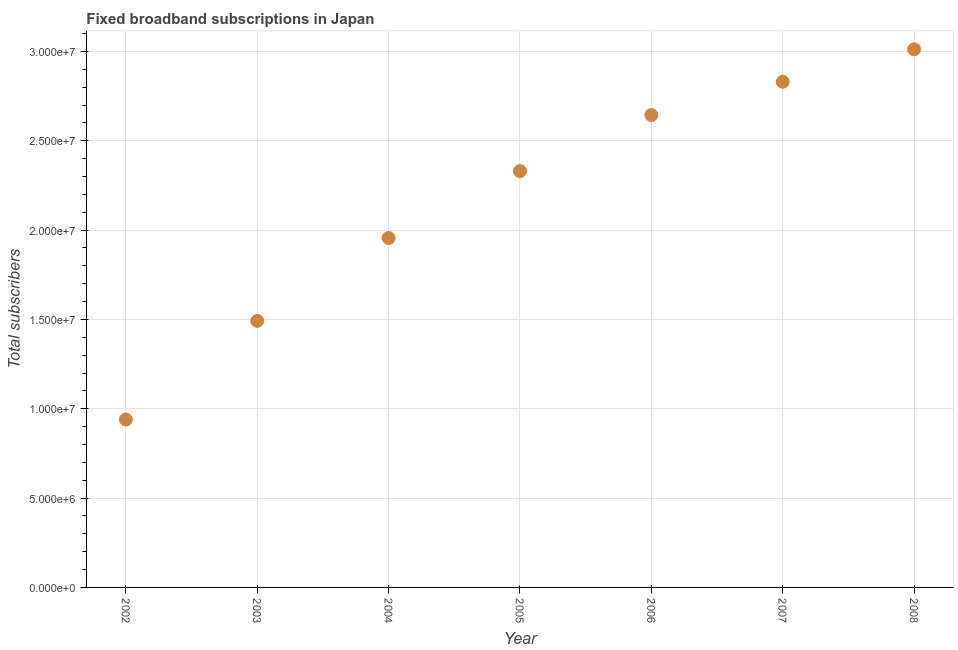What is the total number of fixed broadband subscriptions in 2004?
Your response must be concise. 1.96e+07. Across all years, what is the maximum total number of fixed broadband subscriptions?
Offer a terse response. 3.01e+07. Across all years, what is the minimum total number of fixed broadband subscriptions?
Keep it short and to the point. 9.40e+06. What is the sum of the total number of fixed broadband subscriptions?
Give a very brief answer. 1.52e+08. What is the difference between the total number of fixed broadband subscriptions in 2002 and 2004?
Your answer should be very brief. -1.02e+07. What is the average total number of fixed broadband subscriptions per year?
Make the answer very short. 2.17e+07. What is the median total number of fixed broadband subscriptions?
Provide a short and direct response. 2.33e+07. In how many years, is the total number of fixed broadband subscriptions greater than 2000000 ?
Your response must be concise. 7. What is the ratio of the total number of fixed broadband subscriptions in 2005 to that in 2008?
Keep it short and to the point. 0.77. Is the total number of fixed broadband subscriptions in 2007 less than that in 2008?
Your response must be concise. Yes. Is the difference between the total number of fixed broadband subscriptions in 2004 and 2005 greater than the difference between any two years?
Provide a short and direct response. No. What is the difference between the highest and the second highest total number of fixed broadband subscriptions?
Offer a terse response. 1.81e+06. What is the difference between the highest and the lowest total number of fixed broadband subscriptions?
Your answer should be compact. 2.07e+07. Does the total number of fixed broadband subscriptions monotonically increase over the years?
Your response must be concise. Yes. How many dotlines are there?
Keep it short and to the point. 1. How many years are there in the graph?
Make the answer very short. 7. What is the difference between two consecutive major ticks on the Y-axis?
Provide a succinct answer. 5.00e+06. Are the values on the major ticks of Y-axis written in scientific E-notation?
Your answer should be very brief. Yes. What is the title of the graph?
Your answer should be very brief. Fixed broadband subscriptions in Japan. What is the label or title of the X-axis?
Ensure brevity in your answer.  Year. What is the label or title of the Y-axis?
Offer a very short reply. Total subscribers. What is the Total subscribers in 2002?
Your answer should be compact. 9.40e+06. What is the Total subscribers in 2003?
Give a very brief answer. 1.49e+07. What is the Total subscribers in 2004?
Offer a terse response. 1.96e+07. What is the Total subscribers in 2005?
Your answer should be very brief. 2.33e+07. What is the Total subscribers in 2006?
Give a very brief answer. 2.64e+07. What is the Total subscribers in 2007?
Give a very brief answer. 2.83e+07. What is the Total subscribers in 2008?
Your answer should be very brief. 3.01e+07. What is the difference between the Total subscribers in 2002 and 2003?
Offer a very short reply. -5.52e+06. What is the difference between the Total subscribers in 2002 and 2004?
Provide a short and direct response. -1.02e+07. What is the difference between the Total subscribers in 2002 and 2005?
Your response must be concise. -1.39e+07. What is the difference between the Total subscribers in 2002 and 2006?
Your answer should be very brief. -1.70e+07. What is the difference between the Total subscribers in 2002 and 2007?
Provide a short and direct response. -1.89e+07. What is the difference between the Total subscribers in 2002 and 2008?
Make the answer very short. -2.07e+07. What is the difference between the Total subscribers in 2003 and 2004?
Give a very brief answer. -4.64e+06. What is the difference between the Total subscribers in 2003 and 2005?
Give a very brief answer. -8.38e+06. What is the difference between the Total subscribers in 2003 and 2006?
Your answer should be compact. -1.15e+07. What is the difference between the Total subscribers in 2003 and 2007?
Ensure brevity in your answer.  -1.34e+07. What is the difference between the Total subscribers in 2003 and 2008?
Ensure brevity in your answer.  -1.52e+07. What is the difference between the Total subscribers in 2004 and 2005?
Your answer should be very brief. -3.74e+06. What is the difference between the Total subscribers in 2004 and 2006?
Provide a short and direct response. -6.88e+06. What is the difference between the Total subscribers in 2004 and 2007?
Provide a short and direct response. -8.75e+06. What is the difference between the Total subscribers in 2004 and 2008?
Make the answer very short. -1.06e+07. What is the difference between the Total subscribers in 2005 and 2006?
Keep it short and to the point. -3.14e+06. What is the difference between the Total subscribers in 2005 and 2007?
Give a very brief answer. -5.00e+06. What is the difference between the Total subscribers in 2005 and 2008?
Offer a terse response. -6.82e+06. What is the difference between the Total subscribers in 2006 and 2007?
Provide a succinct answer. -1.86e+06. What is the difference between the Total subscribers in 2006 and 2008?
Your answer should be very brief. -3.68e+06. What is the difference between the Total subscribers in 2007 and 2008?
Your response must be concise. -1.81e+06. What is the ratio of the Total subscribers in 2002 to that in 2003?
Keep it short and to the point. 0.63. What is the ratio of the Total subscribers in 2002 to that in 2004?
Your response must be concise. 0.48. What is the ratio of the Total subscribers in 2002 to that in 2005?
Offer a very short reply. 0.4. What is the ratio of the Total subscribers in 2002 to that in 2006?
Your answer should be very brief. 0.35. What is the ratio of the Total subscribers in 2002 to that in 2007?
Provide a short and direct response. 0.33. What is the ratio of the Total subscribers in 2002 to that in 2008?
Provide a short and direct response. 0.31. What is the ratio of the Total subscribers in 2003 to that in 2004?
Offer a terse response. 0.76. What is the ratio of the Total subscribers in 2003 to that in 2005?
Your answer should be very brief. 0.64. What is the ratio of the Total subscribers in 2003 to that in 2006?
Offer a terse response. 0.56. What is the ratio of the Total subscribers in 2003 to that in 2007?
Your answer should be very brief. 0.53. What is the ratio of the Total subscribers in 2003 to that in 2008?
Your answer should be very brief. 0.49. What is the ratio of the Total subscribers in 2004 to that in 2005?
Provide a short and direct response. 0.84. What is the ratio of the Total subscribers in 2004 to that in 2006?
Ensure brevity in your answer.  0.74. What is the ratio of the Total subscribers in 2004 to that in 2007?
Your response must be concise. 0.69. What is the ratio of the Total subscribers in 2004 to that in 2008?
Keep it short and to the point. 0.65. What is the ratio of the Total subscribers in 2005 to that in 2006?
Your answer should be very brief. 0.88. What is the ratio of the Total subscribers in 2005 to that in 2007?
Offer a very short reply. 0.82. What is the ratio of the Total subscribers in 2005 to that in 2008?
Your answer should be compact. 0.77. What is the ratio of the Total subscribers in 2006 to that in 2007?
Ensure brevity in your answer.  0.93. What is the ratio of the Total subscribers in 2006 to that in 2008?
Keep it short and to the point. 0.88. What is the ratio of the Total subscribers in 2007 to that in 2008?
Make the answer very short. 0.94. 